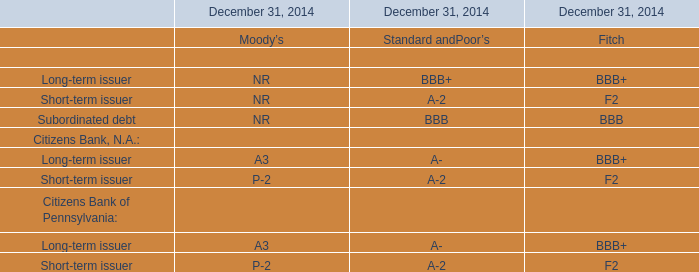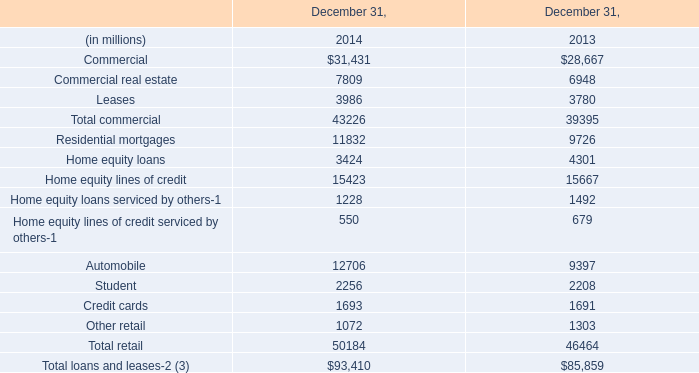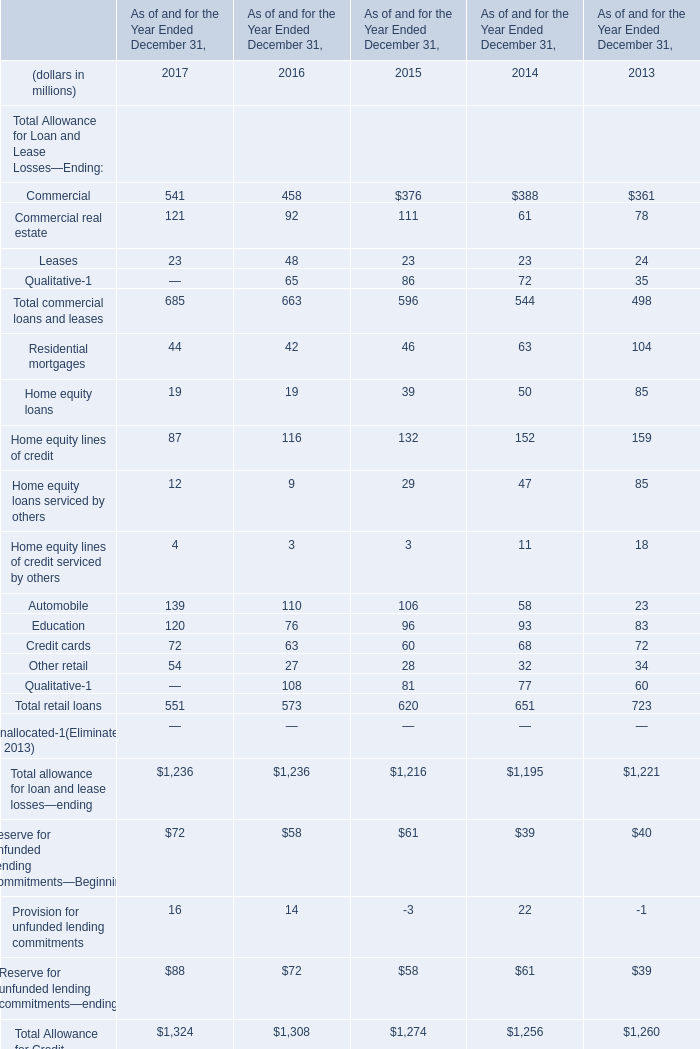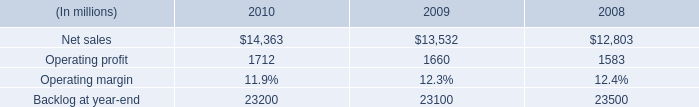what is the growth rate in the net sales from 2008 to 2009? 
Computations: ((13532 - 12803) / 12803)
Answer: 0.05694. 